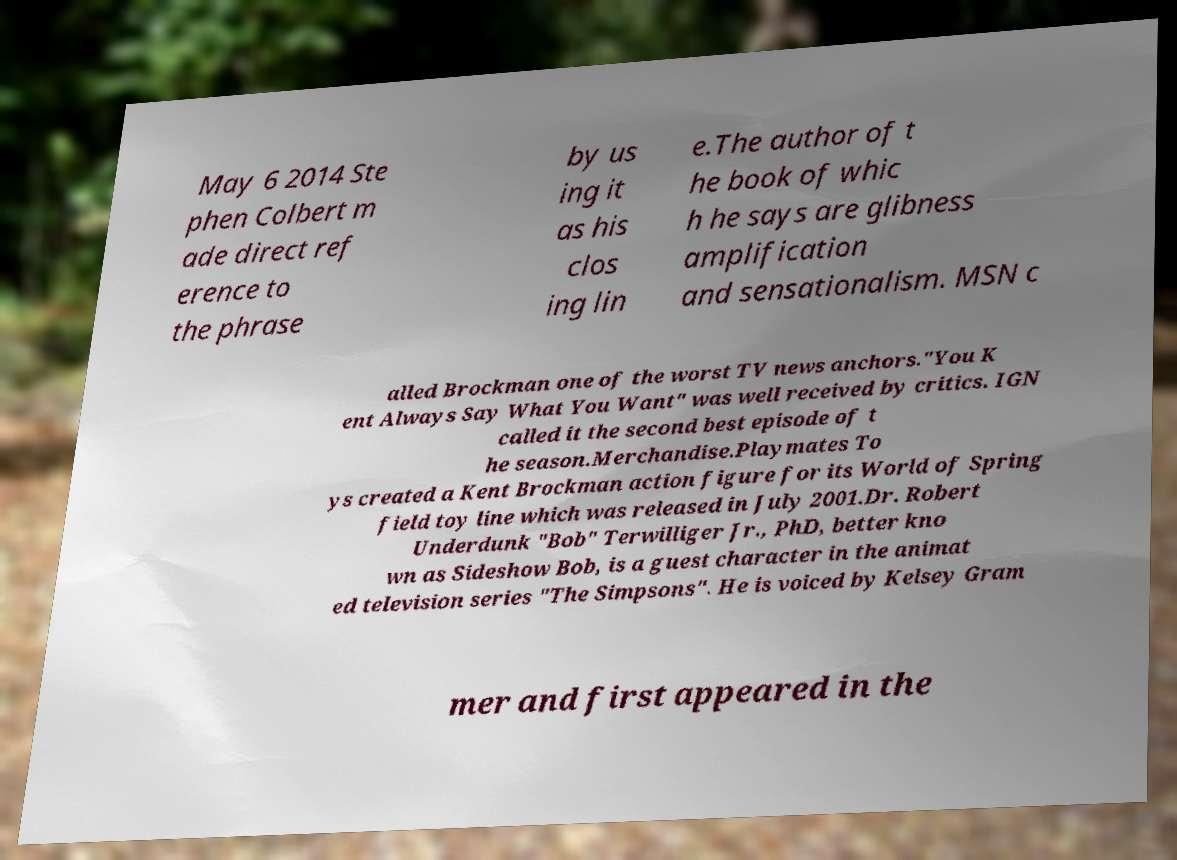Could you assist in decoding the text presented in this image and type it out clearly? May 6 2014 Ste phen Colbert m ade direct ref erence to the phrase by us ing it as his clos ing lin e.The author of t he book of whic h he says are glibness amplification and sensationalism. MSN c alled Brockman one of the worst TV news anchors."You K ent Always Say What You Want" was well received by critics. IGN called it the second best episode of t he season.Merchandise.Playmates To ys created a Kent Brockman action figure for its World of Spring field toy line which was released in July 2001.Dr. Robert Underdunk "Bob" Terwilliger Jr., PhD, better kno wn as Sideshow Bob, is a guest character in the animat ed television series "The Simpsons". He is voiced by Kelsey Gram mer and first appeared in the 